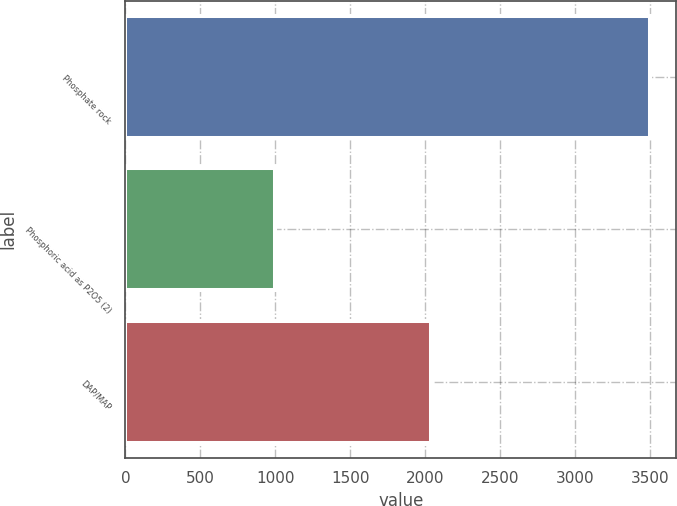Convert chart. <chart><loc_0><loc_0><loc_500><loc_500><bar_chart><fcel>Phosphate rock<fcel>Phosphoric acid as P2O5 (2)<fcel>DAP/MAP<nl><fcel>3500<fcel>1000<fcel>2040<nl></chart> 